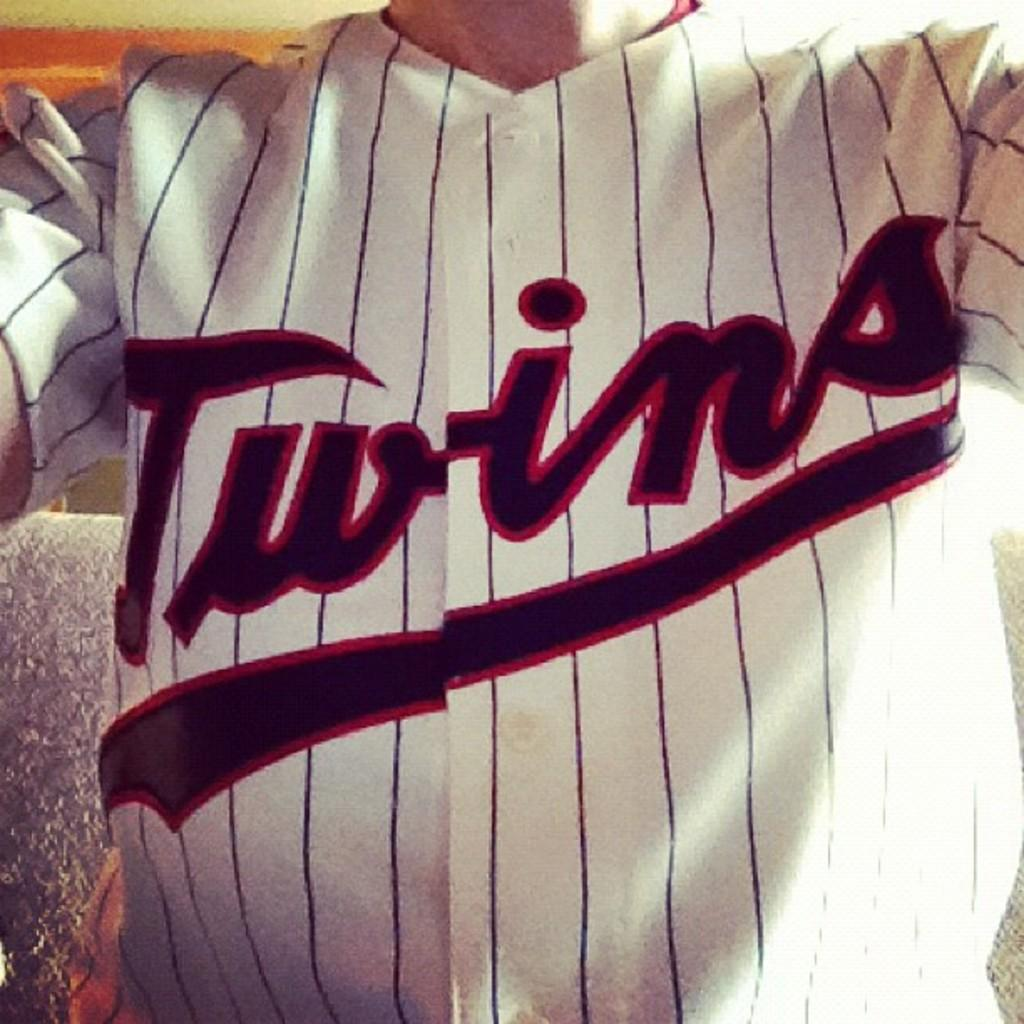<image>
Relay a brief, clear account of the picture shown. A close up of a person where only the torso is visible is wearing a Twins jersey. 